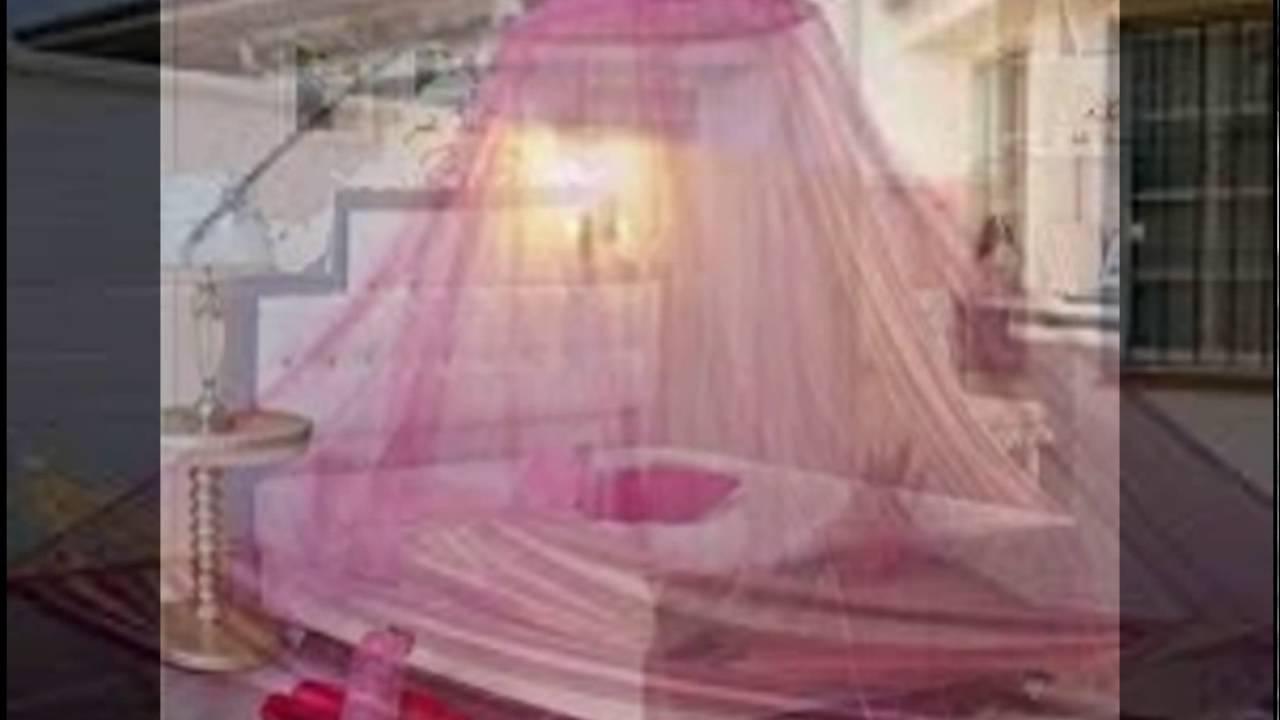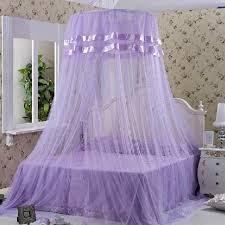The first image is the image on the left, the second image is the image on the right. Evaluate the accuracy of this statement regarding the images: "There is a stuffed animal on top of one of the beds.". Is it true? Answer yes or no. No. 